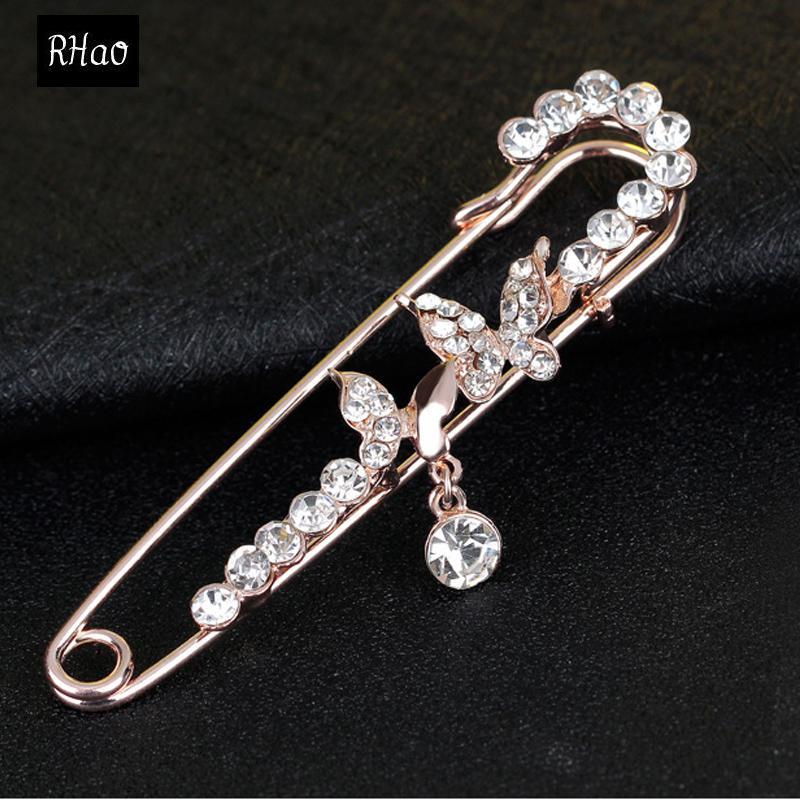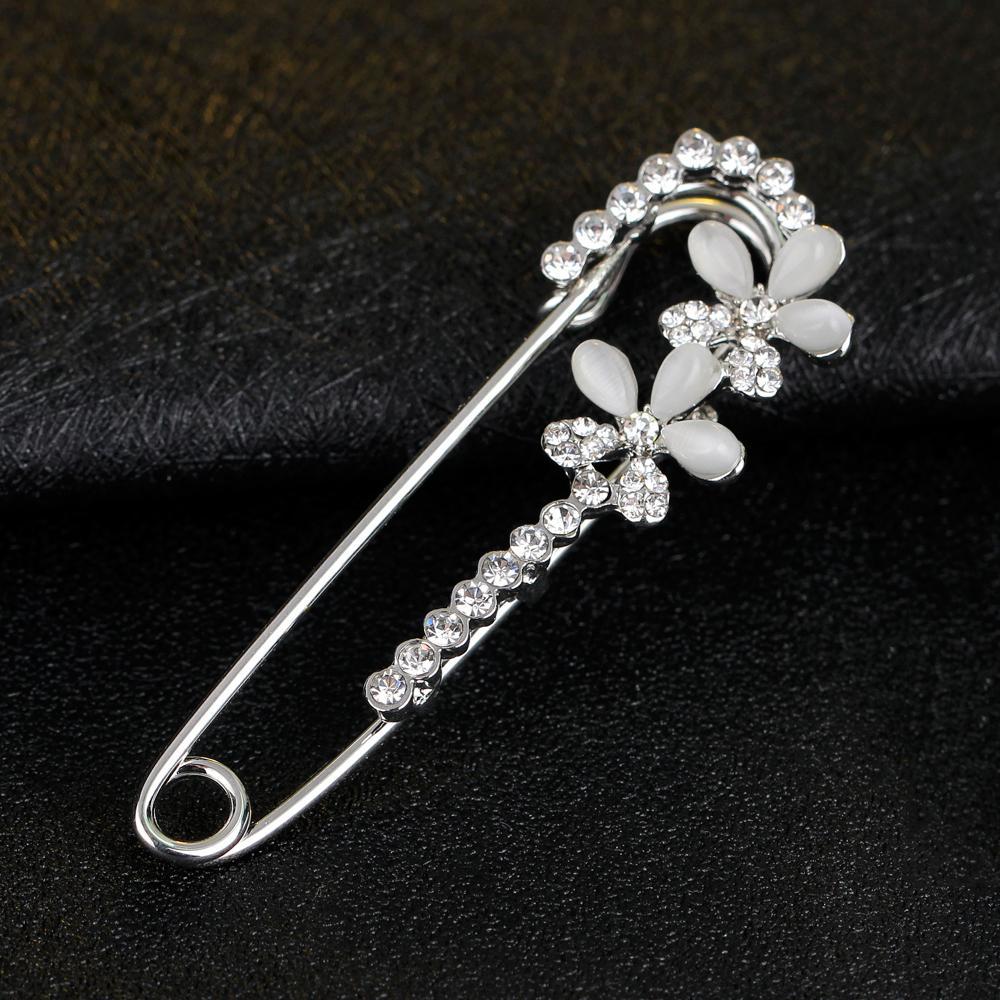The first image is the image on the left, the second image is the image on the right. For the images displayed, is the sentence "1 safety pin is in front of a white dish." factually correct? Answer yes or no. No. 